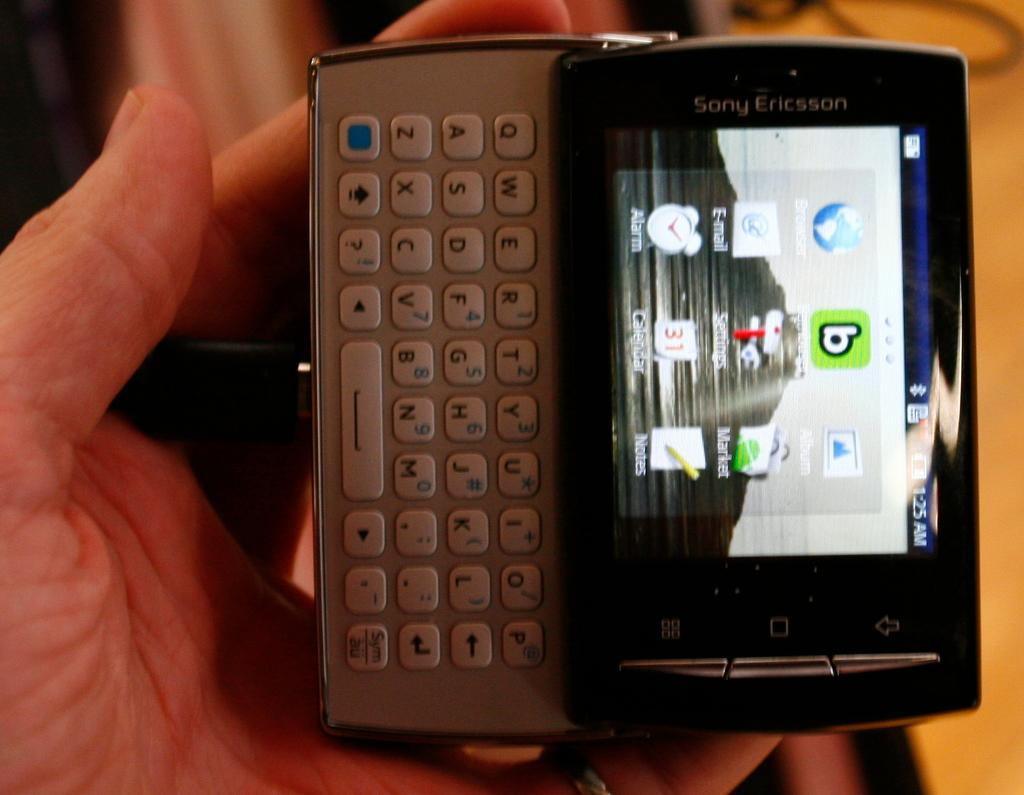<image>
Relay a brief, clear account of the picture shown. A Sony Ericcson device with a slide out QWERTY keyboard. 